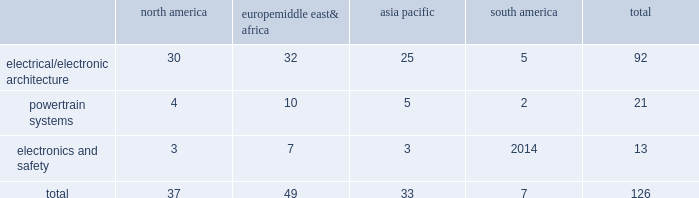Table of contents item 1b .
Unresolved staff comments we have no unresolved sec staff comments to report .
Item 2 .
Properties as of december 31 , 2015 , we owned or leased 126 major manufacturing sites and 14 major technical centers .
A manufacturing site may include multiple plants and may be wholly or partially owned or leased .
We also have many smaller manufacturing sites , sales offices , warehouses , engineering centers , joint ventures and other investments strategically located throughout the world .
We have a presence in 44 countries .
The table shows the regional distribution of our major manufacturing sites by the operating segment that uses such facilities : north america europe , middle east & africa asia pacific south america total .
In addition to these manufacturing sites , we had 14 major technical centers : four in north america ; five in europe , middle east and africa ; four in asia pacific ; and one in south america .
Of our 126 major manufacturing sites and 14 major technical centers , which include facilities owned or leased by our consolidated subsidiaries , 77 are primarily owned and 63 are primarily leased .
We frequently review our real estate portfolio and develop footprint strategies to support our customers 2019 global plans , while at the same time supporting our technical needs and controlling operating expenses .
We believe our evolving portfolio will meet current and anticipated future needs .
Item 3 .
Legal proceedings we are from time to time subject to various actions , claims , suits , government investigations , and other proceedings incidental to our business , including those arising out of alleged defects , breach of contracts , competition and antitrust matters , product warranties , intellectual property matters , personal injury claims and employment-related matters .
It is our opinion that the outcome of such matters will not have a material adverse impact on our consolidated financial position , results of operations , or cash flows .
With respect to warranty matters , although we cannot ensure that the future costs of warranty claims by customers will not be material , we believe our established reserves are adequate to cover potential warranty settlements .
However , the final amounts required to resolve these matters could differ materially from our recorded estimates .
Gm ignition switch recall in the first quarter of 2014 , gm , delphi 2019s largest customer , initiated a product recall related to ignition switches .
Delphi received requests for information from , and cooperated with , various government agencies related to this ignition switch recall .
In addition , delphi was initially named as a co-defendant along with gm ( and in certain cases other parties ) in class action and product liability lawsuits related to this matter .
As of december 31 , 2015 , delphi was not named as a defendant in any class action complaints .
Although no assurances can be made as to the ultimate outcome of these or any other future claims , delphi does not believe a loss is probable and , accordingly , no reserve has been made as of december 31 , 2015 .
Unsecured creditors litigation the fourth amended and restated limited liability partnership agreement of delphi automotive llp ( the 201cfourth llp agreement 201d ) was entered into on july 12 , 2011 by the members of delphi automotive llp in order to position the company for its initial public offering .
Under the terms of the fourth llp agreement , if cumulative distributions to the members of delphi automotive llp under certain provisions of the fourth llp agreement exceed $ 7.2 billion , delphi , as disbursing agent on behalf of dphh , is required to pay to the holders of allowed general unsecured claims against dphh $ 32.50 for every $ 67.50 in excess of $ 7.2 billion distributed to the members , up to a maximum amount of $ 300 million .
In december 2014 , a complaint was filed in the bankruptcy court alleging that the redemption by delphi automotive llp of the membership interests of gm and the pbgc , and the repurchase of shares and payment of dividends by delphi automotive plc , constituted distributions under the terms of the fourth llp agreement approximating $ 7.2 billion .
Delphi considers cumulative .
What percentage of major manufacturing sites are in asia pacific? 
Computations: (33 / 126)
Answer: 0.2619. 